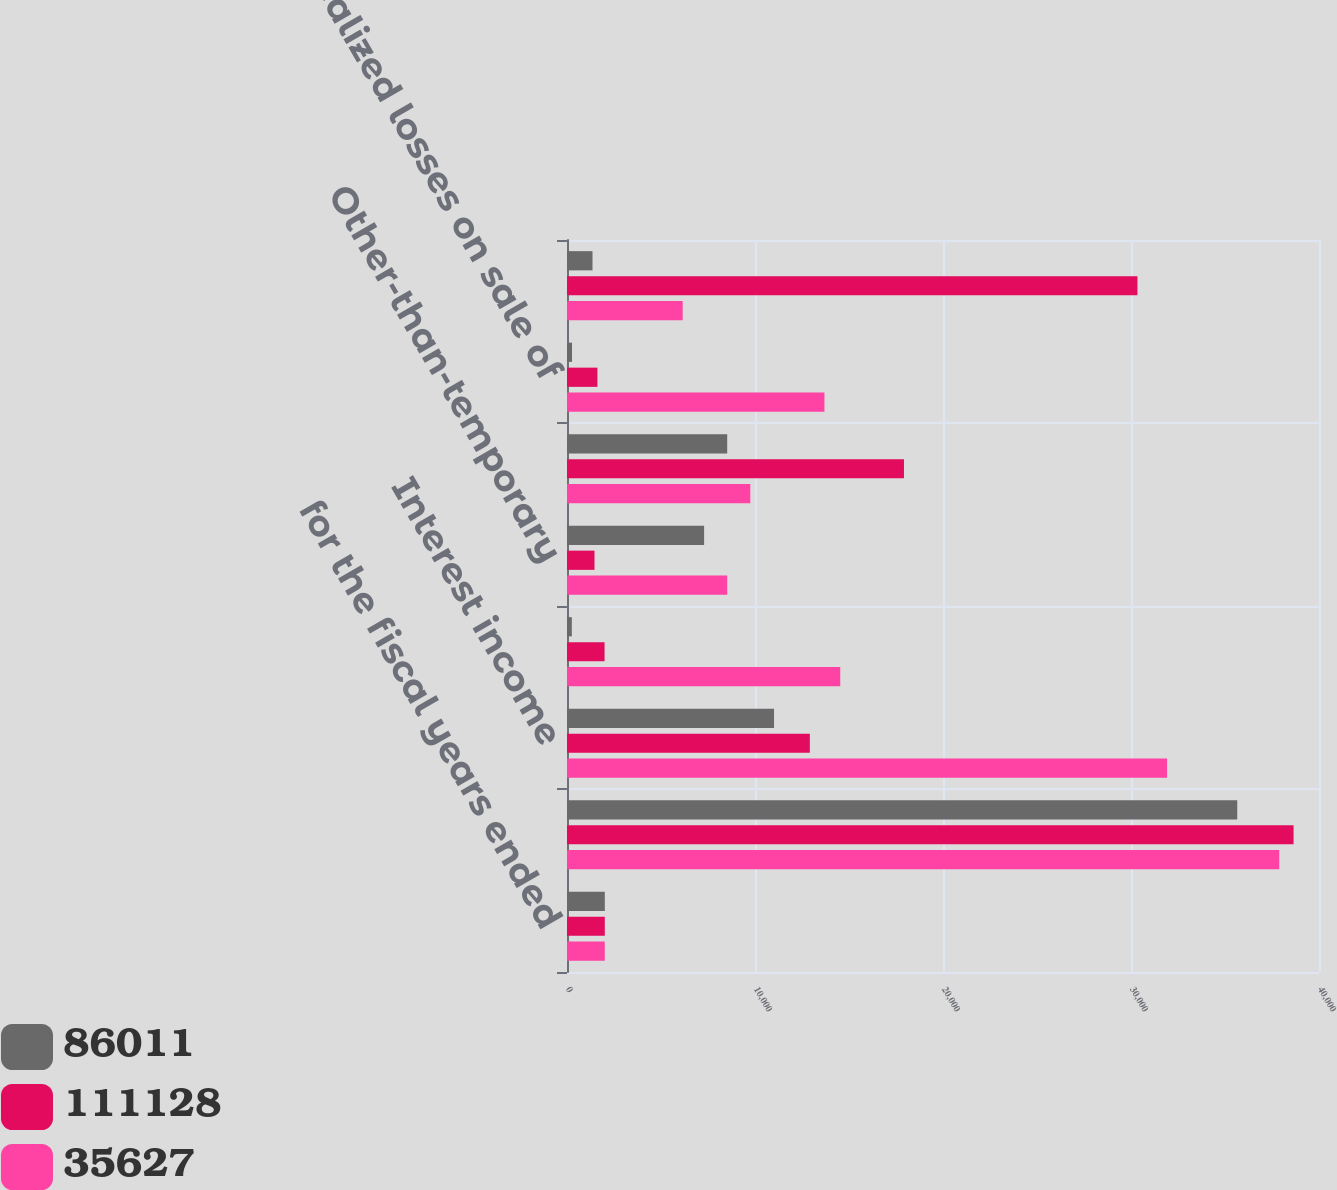<chart> <loc_0><loc_0><loc_500><loc_500><stacked_bar_chart><ecel><fcel>for the fiscal years ended<fcel>Dividend income<fcel>Interest income<fcel>Capital gain distributions<fcel>Other-than-temporary<fcel>Realized gains on sale of<fcel>Realized losses on sale of<fcel>Gains (losses) on trading<nl><fcel>86011<fcel>2011<fcel>35652<fcel>11013<fcel>256<fcel>7293<fcel>8521.5<fcel>267<fcel>1356<nl><fcel>111128<fcel>2010<fcel>38647<fcel>12917<fcel>1998<fcel>1463<fcel>17924<fcel>1619<fcel>30343<nl><fcel>35627<fcel>2009<fcel>37886<fcel>31918<fcel>14535<fcel>8521.5<fcel>9750<fcel>13694<fcel>6154<nl></chart> 